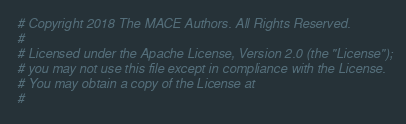<code> <loc_0><loc_0><loc_500><loc_500><_Python_># Copyright 2018 The MACE Authors. All Rights Reserved.
#
# Licensed under the Apache License, Version 2.0 (the "License");
# you may not use this file except in compliance with the License.
# You may obtain a copy of the License at
#</code> 